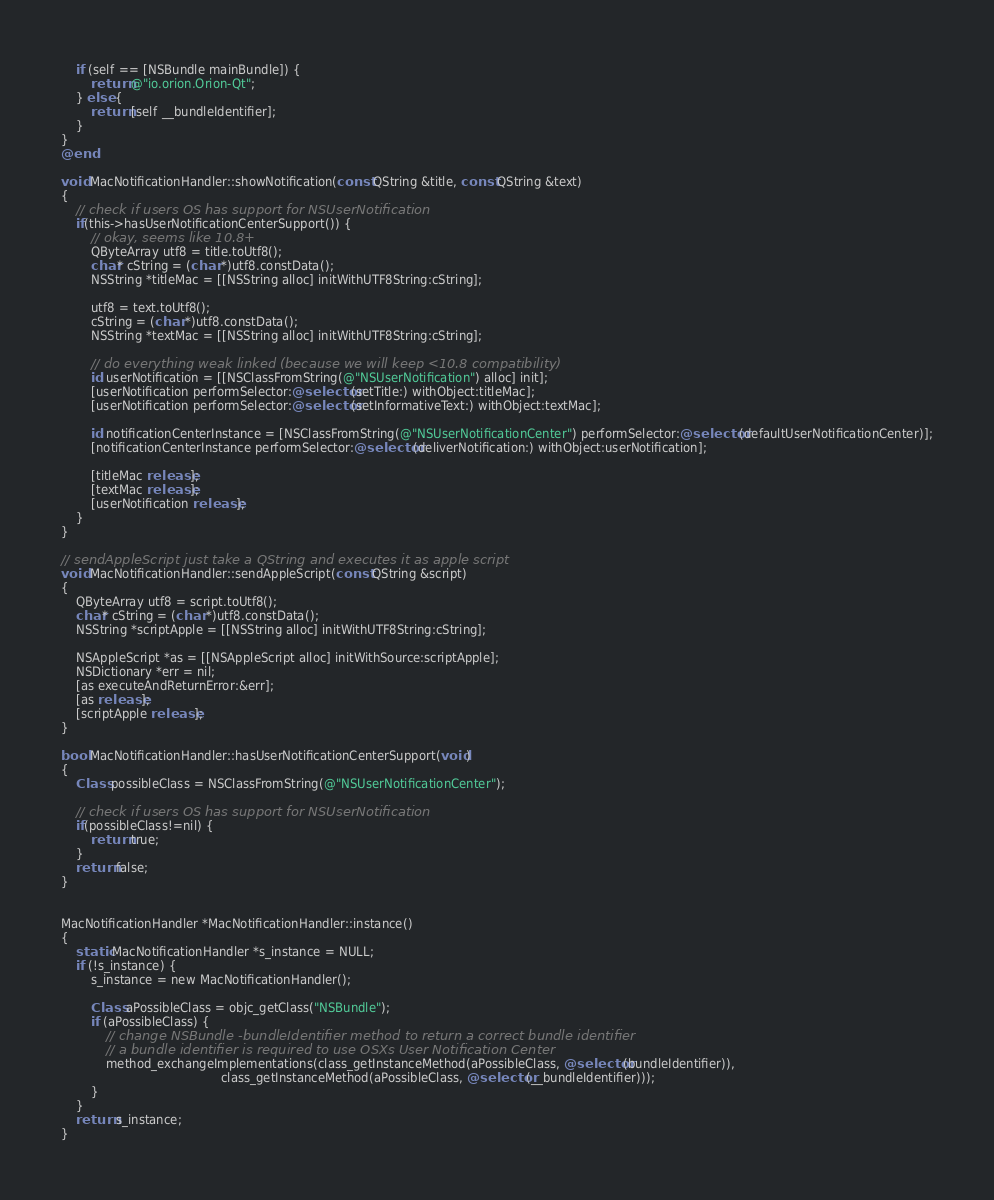<code> <loc_0><loc_0><loc_500><loc_500><_ObjectiveC_>    if (self == [NSBundle mainBundle]) {
        return @"io.orion.Orion-Qt";
    } else {
        return [self __bundleIdentifier];
    }
}
@end

void MacNotificationHandler::showNotification(const QString &title, const QString &text)
{
    // check if users OS has support for NSUserNotification
    if(this->hasUserNotificationCenterSupport()) {
        // okay, seems like 10.8+
        QByteArray utf8 = title.toUtf8();
        char* cString = (char *)utf8.constData();
        NSString *titleMac = [[NSString alloc] initWithUTF8String:cString];

        utf8 = text.toUtf8();
        cString = (char *)utf8.constData();
        NSString *textMac = [[NSString alloc] initWithUTF8String:cString];

        // do everything weak linked (because we will keep <10.8 compatibility)
        id userNotification = [[NSClassFromString(@"NSUserNotification") alloc] init];
        [userNotification performSelector:@selector(setTitle:) withObject:titleMac];
        [userNotification performSelector:@selector(setInformativeText:) withObject:textMac];

        id notificationCenterInstance = [NSClassFromString(@"NSUserNotificationCenter") performSelector:@selector(defaultUserNotificationCenter)];
        [notificationCenterInstance performSelector:@selector(deliverNotification:) withObject:userNotification];

        [titleMac release];
        [textMac release];
        [userNotification release];
    }
}

// sendAppleScript just take a QString and executes it as apple script
void MacNotificationHandler::sendAppleScript(const QString &script)
{
    QByteArray utf8 = script.toUtf8();
    char* cString = (char *)utf8.constData();
    NSString *scriptApple = [[NSString alloc] initWithUTF8String:cString];

    NSAppleScript *as = [[NSAppleScript alloc] initWithSource:scriptApple];
    NSDictionary *err = nil;
    [as executeAndReturnError:&err];
    [as release];
    [scriptApple release];
}

bool MacNotificationHandler::hasUserNotificationCenterSupport(void)
{
    Class possibleClass = NSClassFromString(@"NSUserNotificationCenter");

    // check if users OS has support for NSUserNotification
    if(possibleClass!=nil) {
        return true;
    }
    return false;
}


MacNotificationHandler *MacNotificationHandler::instance()
{
    static MacNotificationHandler *s_instance = NULL;
    if (!s_instance) {
        s_instance = new MacNotificationHandler();
        
        Class aPossibleClass = objc_getClass("NSBundle");
        if (aPossibleClass) {
            // change NSBundle -bundleIdentifier method to return a correct bundle identifier
            // a bundle identifier is required to use OSXs User Notification Center
            method_exchangeImplementations(class_getInstanceMethod(aPossibleClass, @selector(bundleIdentifier)),
                                           class_getInstanceMethod(aPossibleClass, @selector(__bundleIdentifier)));
        }
    }
    return s_instance;
}
</code> 